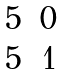<formula> <loc_0><loc_0><loc_500><loc_500>\begin{matrix} 5 & 0 \\ 5 & 1 \end{matrix}</formula> 